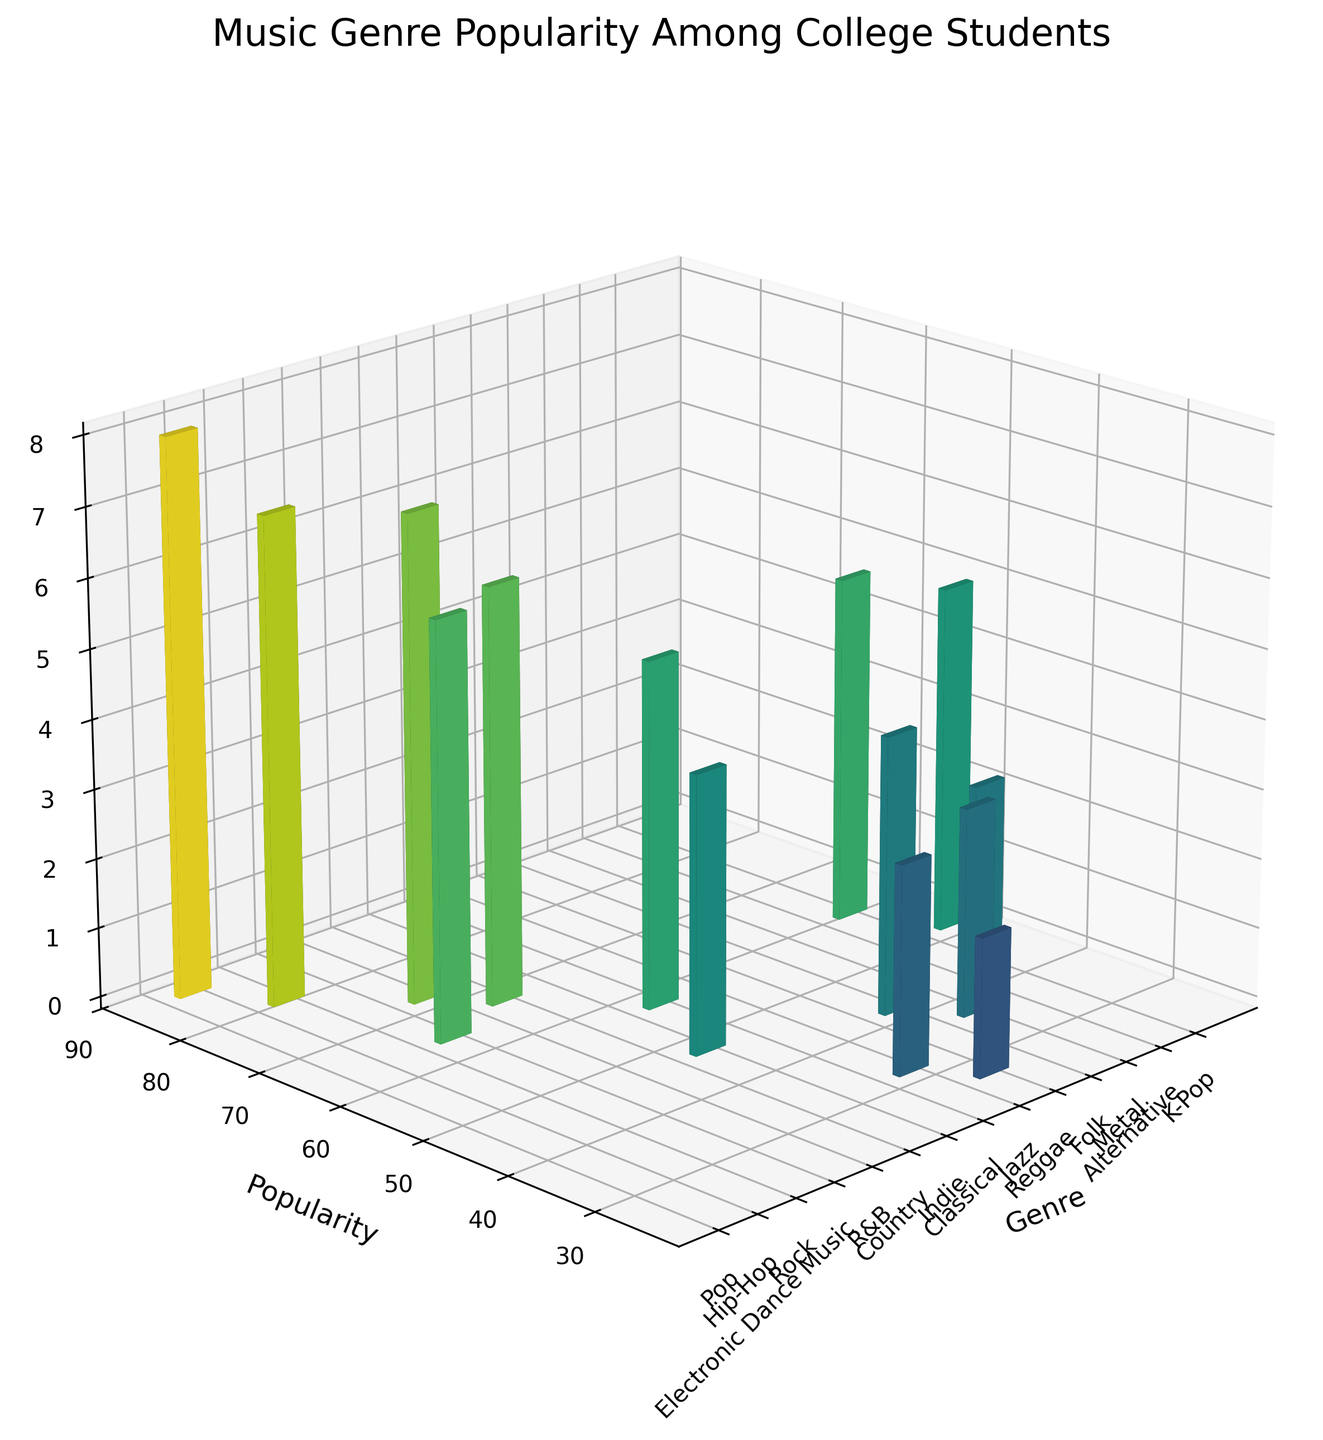What is the title of the figure? The title of the figure is typically positioned at the top and summarized in the largest font size. Here, it's easy to spot above the 3D bars.
Answer: Music Genre Popularity Among College Students How many music genres are represented in the figure? You can count the number of unique bars or positions along the x-axis, which corresponds to the number of genres.
Answer: 14 Which genre has the highest popularity? By visually comparing the heights of the bars, you can identify the tallest bar. The genre label corresponding to this bar is the one with the highest popularity.
Answer: Pop What is the total popularity for Rock and Country genres combined? Locate the bars representing Rock and Country, then sum their popularity values seen on the y-axis. Rock has a popularity of 62 and Country has 45. Adding these gives 62 + 45.
Answer: 107 Which genre has a greater popularity, Jazz or Folk? Compare the heights and y-values of the Jazz and Folk bars. Jazz has a popularity value of 25 while Folk has 35.
Answer: Folk How does the popularity of Hip-Hop compare to Electronic Dance Music? Look at the heights and y-values of Hip-Hop and Electronic Dance Music. Hip-Hop is at 78 and Electronic Dance Music is at 70.
Answer: Hip-Hop is more popular What is the median popularity value of the genres shown? List the popularity values in order (25, 30, 35, 38, 40, 45, 50, 55, 58, 62, 65, 70, 78, 85). The median is the middle value. Since there are 14 values, take the average of the 7th and 8th values (50 and 55). (50+55)/2 = 52.5.
Answer: 52.5 Which genre has a popularity between Classical and Metal? Find the popularity values for Classical (30) and Metal (38). The genre with a popularity in between these values is Folk at 35.
Answer: Folk What is the average height of bars for genres with popularity values above 60? Identify the genres with popularity > 60 (Pop, Hip-Hop, Rock, Electronic Dance Music, R&B). Their heights are 8, 7, 6, 7, 6. Calculate the average: (8 + 7 + 6 + 7 + 6) / 5 = 6.8.
Answer: 6.8 If you were to group genres by their heights, which genres have the height exactly 5? Observe the heights and find genres with a height of 5. The genres are Indie, Alternative, and K-Pop.
Answer: Indie, Alternative, and K-Pop 